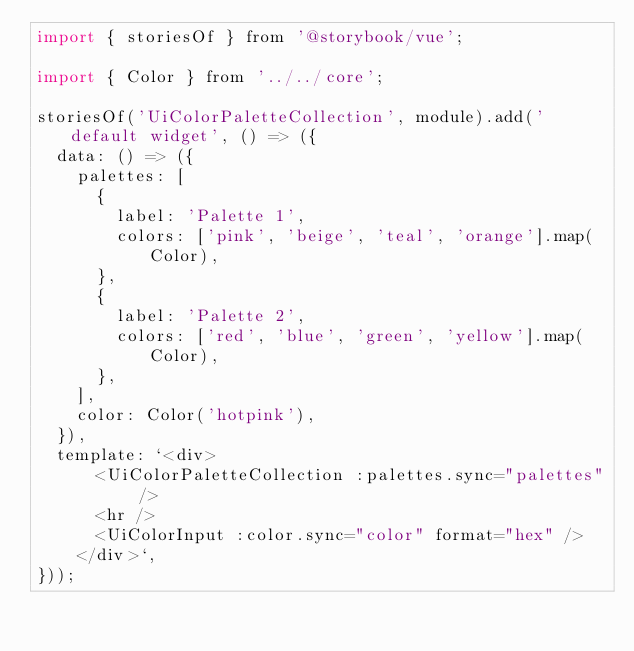<code> <loc_0><loc_0><loc_500><loc_500><_JavaScript_>import { storiesOf } from '@storybook/vue';

import { Color } from '../../core';

storiesOf('UiColorPaletteCollection', module).add('default widget', () => ({
  data: () => ({
    palettes: [
      {
        label: 'Palette 1',
        colors: ['pink', 'beige', 'teal', 'orange'].map(Color),
      },
      {
        label: 'Palette 2',
        colors: ['red', 'blue', 'green', 'yellow'].map(Color),
      },
    ],
    color: Color('hotpink'),
  }),
  template: `<div>
      <UiColorPaletteCollection :palettes.sync="palettes" />
      <hr />
      <UiColorInput :color.sync="color" format="hex" />
    </div>`,
}));
</code> 